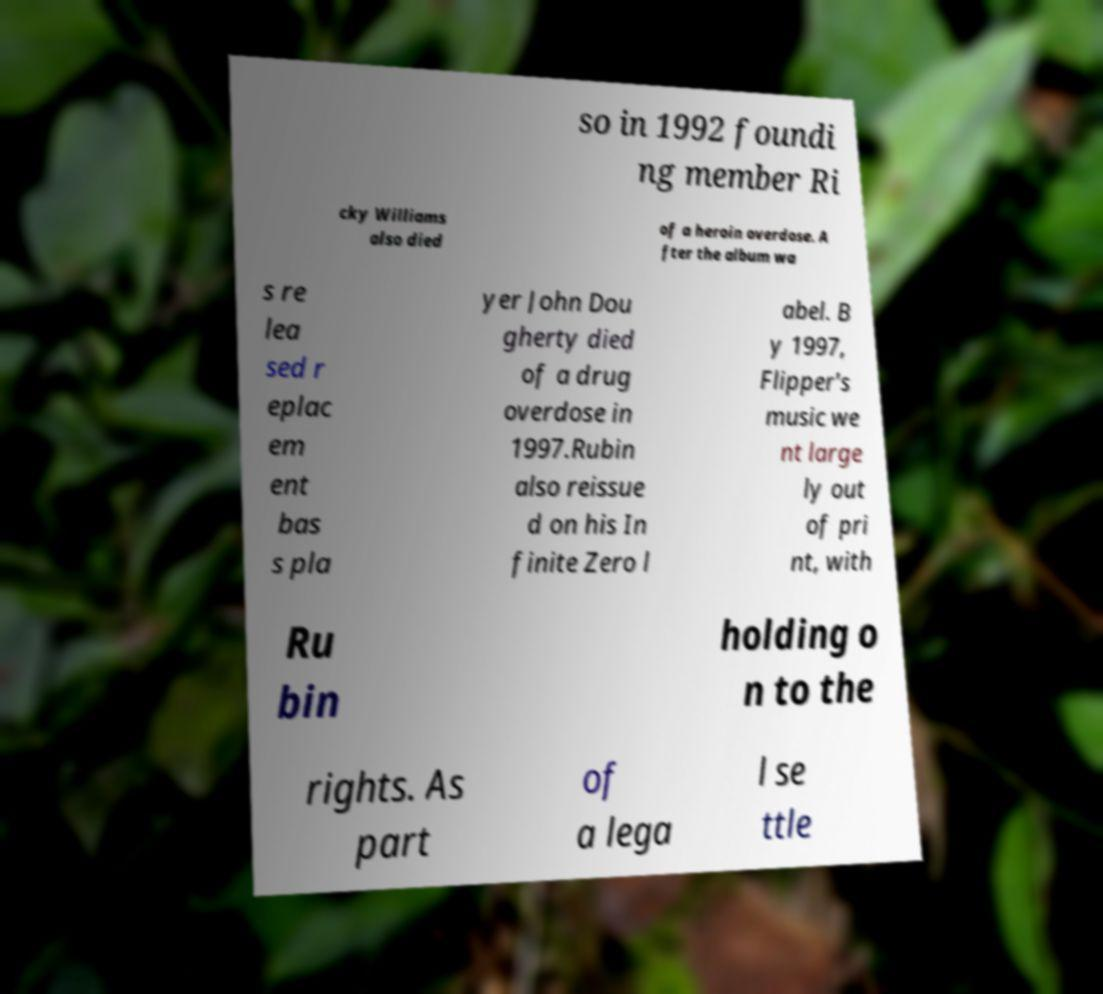What messages or text are displayed in this image? I need them in a readable, typed format. so in 1992 foundi ng member Ri cky Williams also died of a heroin overdose. A fter the album wa s re lea sed r eplac em ent bas s pla yer John Dou gherty died of a drug overdose in 1997.Rubin also reissue d on his In finite Zero l abel. B y 1997, Flipper's music we nt large ly out of pri nt, with Ru bin holding o n to the rights. As part of a lega l se ttle 